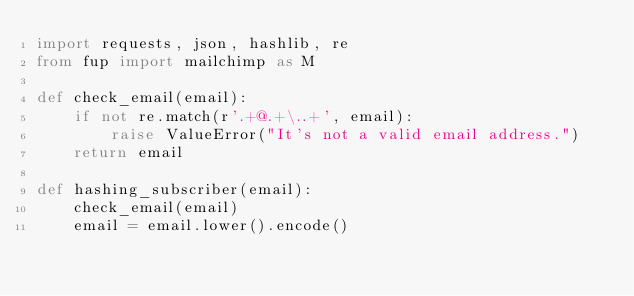<code> <loc_0><loc_0><loc_500><loc_500><_Python_>import requests, json, hashlib, re
from fup import mailchimp as M

def check_email(email):
    if not re.match(r'.+@.+\..+', email):
        raise ValueError("It's not a valid email address.")
    return email

def hashing_subscriber(email):
    check_email(email)
    email = email.lower().encode()</code> 